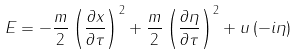<formula> <loc_0><loc_0><loc_500><loc_500>E = - \frac { m } { 2 } \left ( \frac { \partial x } { \partial \tau } \right ) ^ { 2 } + \frac { m } { 2 } \left ( \frac { \partial \eta } { \partial \tau } \right ) ^ { 2 } + u \left ( - i \eta \right )</formula> 